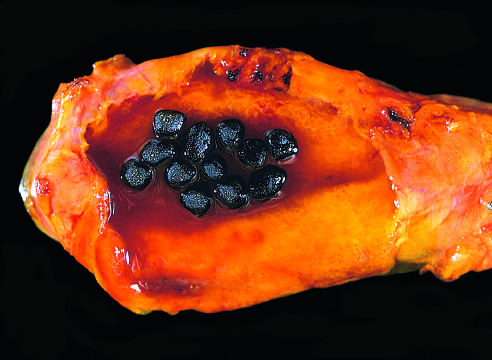what are several faceted black gallstones present in?
Answer the question using a single word or phrase. The gallbladder from a patient with a mechanical mitral valve prosthesis 